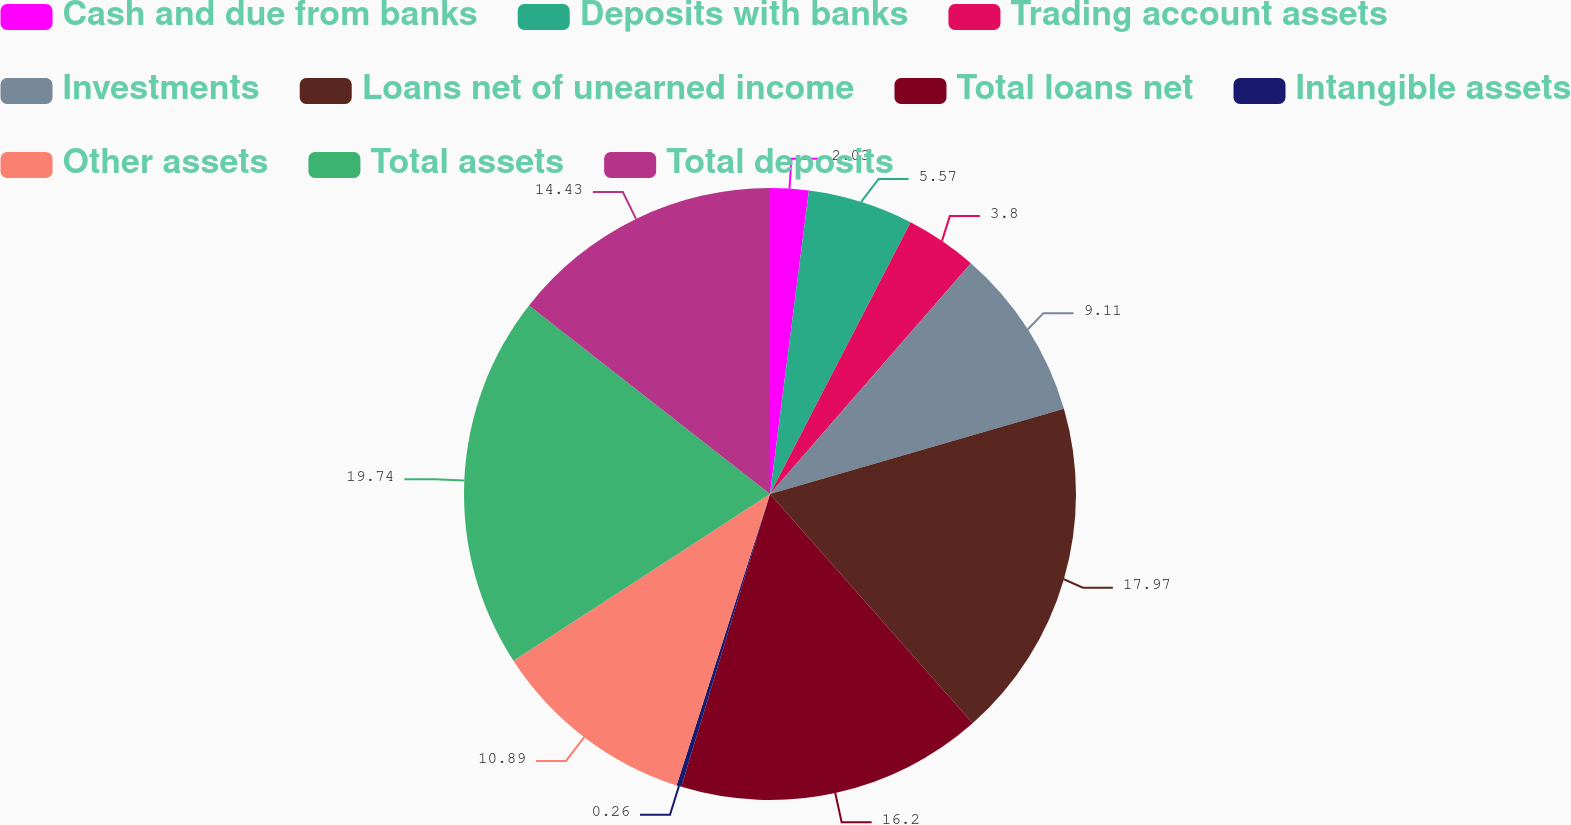<chart> <loc_0><loc_0><loc_500><loc_500><pie_chart><fcel>Cash and due from banks<fcel>Deposits with banks<fcel>Trading account assets<fcel>Investments<fcel>Loans net of unearned income<fcel>Total loans net<fcel>Intangible assets<fcel>Other assets<fcel>Total assets<fcel>Total deposits<nl><fcel>2.03%<fcel>5.57%<fcel>3.8%<fcel>9.11%<fcel>17.97%<fcel>16.2%<fcel>0.26%<fcel>10.89%<fcel>19.74%<fcel>14.43%<nl></chart> 